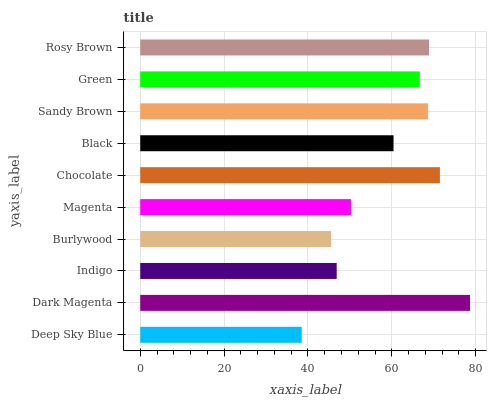Is Deep Sky Blue the minimum?
Answer yes or no. Yes. Is Dark Magenta the maximum?
Answer yes or no. Yes. Is Indigo the minimum?
Answer yes or no. No. Is Indigo the maximum?
Answer yes or no. No. Is Dark Magenta greater than Indigo?
Answer yes or no. Yes. Is Indigo less than Dark Magenta?
Answer yes or no. Yes. Is Indigo greater than Dark Magenta?
Answer yes or no. No. Is Dark Magenta less than Indigo?
Answer yes or no. No. Is Green the high median?
Answer yes or no. Yes. Is Black the low median?
Answer yes or no. Yes. Is Indigo the high median?
Answer yes or no. No. Is Deep Sky Blue the low median?
Answer yes or no. No. 